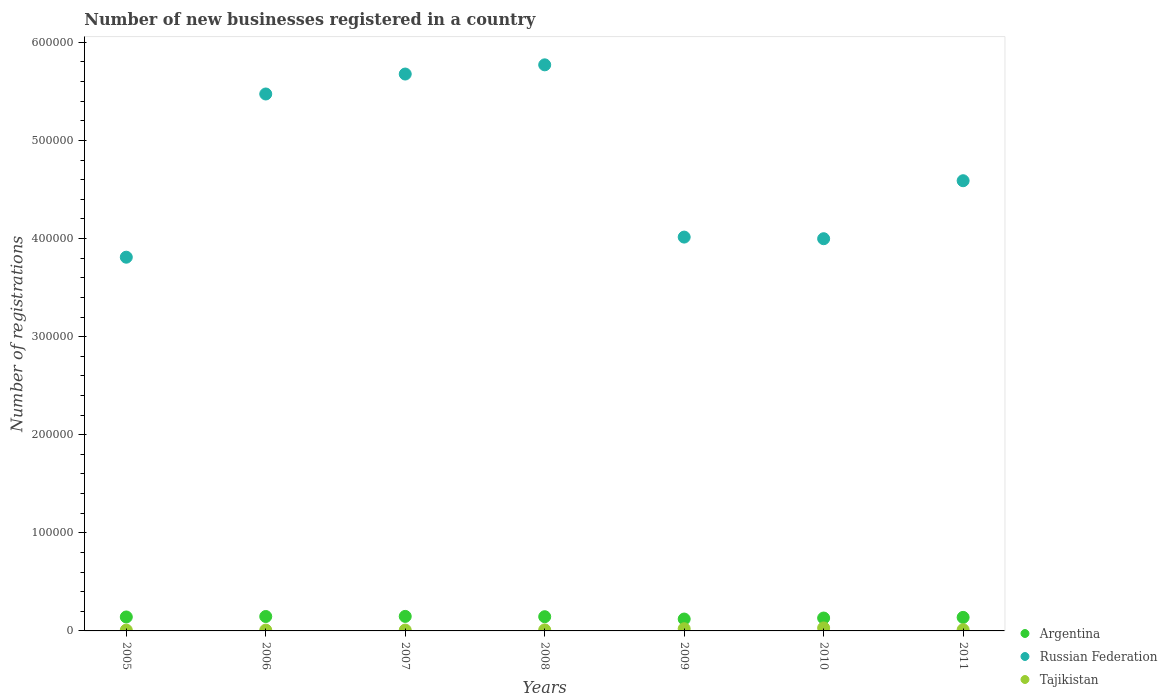Is the number of dotlines equal to the number of legend labels?
Your response must be concise. Yes. What is the number of new businesses registered in Tajikistan in 2008?
Ensure brevity in your answer.  1059. Across all years, what is the maximum number of new businesses registered in Tajikistan?
Give a very brief answer. 3048. Across all years, what is the minimum number of new businesses registered in Argentina?
Keep it short and to the point. 1.21e+04. What is the total number of new businesses registered in Russian Federation in the graph?
Offer a very short reply. 3.33e+06. What is the difference between the number of new businesses registered in Russian Federation in 2005 and that in 2009?
Your answer should be compact. -2.05e+04. What is the difference between the number of new businesses registered in Argentina in 2006 and the number of new businesses registered in Russian Federation in 2008?
Offer a very short reply. -5.62e+05. What is the average number of new businesses registered in Argentina per year?
Your response must be concise. 1.39e+04. In the year 2008, what is the difference between the number of new businesses registered in Tajikistan and number of new businesses registered in Argentina?
Offer a very short reply. -1.34e+04. In how many years, is the number of new businesses registered in Tajikistan greater than 580000?
Provide a succinct answer. 0. What is the ratio of the number of new businesses registered in Argentina in 2007 to that in 2010?
Your response must be concise. 1.13. Is the difference between the number of new businesses registered in Tajikistan in 2007 and 2008 greater than the difference between the number of new businesses registered in Argentina in 2007 and 2008?
Your answer should be very brief. No. What is the difference between the highest and the second highest number of new businesses registered in Russian Federation?
Offer a very short reply. 9377. What is the difference between the highest and the lowest number of new businesses registered in Tajikistan?
Offer a very short reply. 2204. In how many years, is the number of new businesses registered in Tajikistan greater than the average number of new businesses registered in Tajikistan taken over all years?
Your answer should be very brief. 2. Is the number of new businesses registered in Tajikistan strictly greater than the number of new businesses registered in Argentina over the years?
Ensure brevity in your answer.  No. Is the number of new businesses registered in Tajikistan strictly less than the number of new businesses registered in Russian Federation over the years?
Your answer should be compact. Yes. How many dotlines are there?
Your answer should be compact. 3. What is the difference between two consecutive major ticks on the Y-axis?
Offer a terse response. 1.00e+05. Are the values on the major ticks of Y-axis written in scientific E-notation?
Keep it short and to the point. No. Does the graph contain grids?
Your response must be concise. No. What is the title of the graph?
Ensure brevity in your answer.  Number of new businesses registered in a country. What is the label or title of the X-axis?
Your answer should be very brief. Years. What is the label or title of the Y-axis?
Keep it short and to the point. Number of registrations. What is the Number of registrations in Argentina in 2005?
Provide a succinct answer. 1.42e+04. What is the Number of registrations in Russian Federation in 2005?
Your answer should be compact. 3.81e+05. What is the Number of registrations of Tajikistan in 2005?
Make the answer very short. 844. What is the Number of registrations of Argentina in 2006?
Your response must be concise. 1.47e+04. What is the Number of registrations in Russian Federation in 2006?
Provide a succinct answer. 5.47e+05. What is the Number of registrations in Tajikistan in 2006?
Make the answer very short. 849. What is the Number of registrations of Argentina in 2007?
Keep it short and to the point. 1.48e+04. What is the Number of registrations of Russian Federation in 2007?
Your response must be concise. 5.68e+05. What is the Number of registrations of Tajikistan in 2007?
Give a very brief answer. 871. What is the Number of registrations of Argentina in 2008?
Keep it short and to the point. 1.45e+04. What is the Number of registrations of Russian Federation in 2008?
Your answer should be compact. 5.77e+05. What is the Number of registrations of Tajikistan in 2008?
Your answer should be very brief. 1059. What is the Number of registrations of Argentina in 2009?
Your answer should be very brief. 1.21e+04. What is the Number of registrations in Russian Federation in 2009?
Provide a succinct answer. 4.01e+05. What is the Number of registrations of Tajikistan in 2009?
Provide a short and direct response. 2219. What is the Number of registrations of Argentina in 2010?
Your answer should be very brief. 1.31e+04. What is the Number of registrations in Russian Federation in 2010?
Ensure brevity in your answer.  4.00e+05. What is the Number of registrations in Tajikistan in 2010?
Offer a very short reply. 3048. What is the Number of registrations in Argentina in 2011?
Your response must be concise. 1.38e+04. What is the Number of registrations of Russian Federation in 2011?
Give a very brief answer. 4.59e+05. What is the Number of registrations in Tajikistan in 2011?
Make the answer very short. 1232. Across all years, what is the maximum Number of registrations in Argentina?
Your answer should be compact. 1.48e+04. Across all years, what is the maximum Number of registrations in Russian Federation?
Keep it short and to the point. 5.77e+05. Across all years, what is the maximum Number of registrations of Tajikistan?
Offer a terse response. 3048. Across all years, what is the minimum Number of registrations in Argentina?
Your answer should be very brief. 1.21e+04. Across all years, what is the minimum Number of registrations of Russian Federation?
Provide a succinct answer. 3.81e+05. Across all years, what is the minimum Number of registrations of Tajikistan?
Offer a very short reply. 844. What is the total Number of registrations of Argentina in the graph?
Provide a short and direct response. 9.73e+04. What is the total Number of registrations in Russian Federation in the graph?
Provide a succinct answer. 3.33e+06. What is the total Number of registrations of Tajikistan in the graph?
Ensure brevity in your answer.  1.01e+04. What is the difference between the Number of registrations in Argentina in 2005 and that in 2006?
Your answer should be very brief. -475. What is the difference between the Number of registrations in Russian Federation in 2005 and that in 2006?
Your answer should be compact. -1.66e+05. What is the difference between the Number of registrations in Argentina in 2005 and that in 2007?
Offer a terse response. -586. What is the difference between the Number of registrations in Russian Federation in 2005 and that in 2007?
Your answer should be very brief. -1.87e+05. What is the difference between the Number of registrations of Tajikistan in 2005 and that in 2007?
Provide a short and direct response. -27. What is the difference between the Number of registrations of Argentina in 2005 and that in 2008?
Your answer should be very brief. -274. What is the difference between the Number of registrations in Russian Federation in 2005 and that in 2008?
Make the answer very short. -1.96e+05. What is the difference between the Number of registrations in Tajikistan in 2005 and that in 2008?
Keep it short and to the point. -215. What is the difference between the Number of registrations of Argentina in 2005 and that in 2009?
Your answer should be very brief. 2101. What is the difference between the Number of registrations in Russian Federation in 2005 and that in 2009?
Make the answer very short. -2.05e+04. What is the difference between the Number of registrations of Tajikistan in 2005 and that in 2009?
Keep it short and to the point. -1375. What is the difference between the Number of registrations of Argentina in 2005 and that in 2010?
Offer a very short reply. 1086. What is the difference between the Number of registrations of Russian Federation in 2005 and that in 2010?
Your answer should be very brief. -1.88e+04. What is the difference between the Number of registrations of Tajikistan in 2005 and that in 2010?
Keep it short and to the point. -2204. What is the difference between the Number of registrations in Argentina in 2005 and that in 2011?
Your answer should be very brief. 420. What is the difference between the Number of registrations of Russian Federation in 2005 and that in 2011?
Provide a short and direct response. -7.80e+04. What is the difference between the Number of registrations of Tajikistan in 2005 and that in 2011?
Provide a succinct answer. -388. What is the difference between the Number of registrations in Argentina in 2006 and that in 2007?
Provide a succinct answer. -111. What is the difference between the Number of registrations in Russian Federation in 2006 and that in 2007?
Give a very brief answer. -2.03e+04. What is the difference between the Number of registrations of Tajikistan in 2006 and that in 2007?
Your answer should be very brief. -22. What is the difference between the Number of registrations of Argentina in 2006 and that in 2008?
Keep it short and to the point. 201. What is the difference between the Number of registrations of Russian Federation in 2006 and that in 2008?
Ensure brevity in your answer.  -2.97e+04. What is the difference between the Number of registrations in Tajikistan in 2006 and that in 2008?
Your response must be concise. -210. What is the difference between the Number of registrations in Argentina in 2006 and that in 2009?
Your answer should be very brief. 2576. What is the difference between the Number of registrations in Russian Federation in 2006 and that in 2009?
Make the answer very short. 1.46e+05. What is the difference between the Number of registrations in Tajikistan in 2006 and that in 2009?
Give a very brief answer. -1370. What is the difference between the Number of registrations in Argentina in 2006 and that in 2010?
Your response must be concise. 1561. What is the difference between the Number of registrations in Russian Federation in 2006 and that in 2010?
Provide a succinct answer. 1.48e+05. What is the difference between the Number of registrations of Tajikistan in 2006 and that in 2010?
Provide a succinct answer. -2199. What is the difference between the Number of registrations in Argentina in 2006 and that in 2011?
Give a very brief answer. 895. What is the difference between the Number of registrations in Russian Federation in 2006 and that in 2011?
Ensure brevity in your answer.  8.84e+04. What is the difference between the Number of registrations in Tajikistan in 2006 and that in 2011?
Give a very brief answer. -383. What is the difference between the Number of registrations in Argentina in 2007 and that in 2008?
Provide a succinct answer. 312. What is the difference between the Number of registrations of Russian Federation in 2007 and that in 2008?
Keep it short and to the point. -9377. What is the difference between the Number of registrations of Tajikistan in 2007 and that in 2008?
Your answer should be compact. -188. What is the difference between the Number of registrations in Argentina in 2007 and that in 2009?
Offer a very short reply. 2687. What is the difference between the Number of registrations in Russian Federation in 2007 and that in 2009?
Ensure brevity in your answer.  1.66e+05. What is the difference between the Number of registrations of Tajikistan in 2007 and that in 2009?
Make the answer very short. -1348. What is the difference between the Number of registrations in Argentina in 2007 and that in 2010?
Provide a short and direct response. 1672. What is the difference between the Number of registrations in Russian Federation in 2007 and that in 2010?
Offer a very short reply. 1.68e+05. What is the difference between the Number of registrations of Tajikistan in 2007 and that in 2010?
Your response must be concise. -2177. What is the difference between the Number of registrations in Argentina in 2007 and that in 2011?
Your answer should be very brief. 1006. What is the difference between the Number of registrations of Russian Federation in 2007 and that in 2011?
Your answer should be compact. 1.09e+05. What is the difference between the Number of registrations in Tajikistan in 2007 and that in 2011?
Offer a terse response. -361. What is the difference between the Number of registrations in Argentina in 2008 and that in 2009?
Your response must be concise. 2375. What is the difference between the Number of registrations of Russian Federation in 2008 and that in 2009?
Your answer should be compact. 1.76e+05. What is the difference between the Number of registrations of Tajikistan in 2008 and that in 2009?
Your answer should be very brief. -1160. What is the difference between the Number of registrations of Argentina in 2008 and that in 2010?
Provide a succinct answer. 1360. What is the difference between the Number of registrations of Russian Federation in 2008 and that in 2010?
Make the answer very short. 1.77e+05. What is the difference between the Number of registrations of Tajikistan in 2008 and that in 2010?
Ensure brevity in your answer.  -1989. What is the difference between the Number of registrations in Argentina in 2008 and that in 2011?
Offer a very short reply. 694. What is the difference between the Number of registrations in Russian Federation in 2008 and that in 2011?
Make the answer very short. 1.18e+05. What is the difference between the Number of registrations of Tajikistan in 2008 and that in 2011?
Provide a succinct answer. -173. What is the difference between the Number of registrations in Argentina in 2009 and that in 2010?
Your response must be concise. -1015. What is the difference between the Number of registrations of Russian Federation in 2009 and that in 2010?
Your answer should be very brief. 1653. What is the difference between the Number of registrations in Tajikistan in 2009 and that in 2010?
Ensure brevity in your answer.  -829. What is the difference between the Number of registrations of Argentina in 2009 and that in 2011?
Your answer should be compact. -1681. What is the difference between the Number of registrations in Russian Federation in 2009 and that in 2011?
Your answer should be very brief. -5.75e+04. What is the difference between the Number of registrations of Tajikistan in 2009 and that in 2011?
Make the answer very short. 987. What is the difference between the Number of registrations in Argentina in 2010 and that in 2011?
Provide a succinct answer. -666. What is the difference between the Number of registrations in Russian Federation in 2010 and that in 2011?
Your answer should be compact. -5.91e+04. What is the difference between the Number of registrations of Tajikistan in 2010 and that in 2011?
Offer a terse response. 1816. What is the difference between the Number of registrations in Argentina in 2005 and the Number of registrations in Russian Federation in 2006?
Give a very brief answer. -5.33e+05. What is the difference between the Number of registrations of Argentina in 2005 and the Number of registrations of Tajikistan in 2006?
Give a very brief answer. 1.34e+04. What is the difference between the Number of registrations of Russian Federation in 2005 and the Number of registrations of Tajikistan in 2006?
Your answer should be very brief. 3.80e+05. What is the difference between the Number of registrations of Argentina in 2005 and the Number of registrations of Russian Federation in 2007?
Give a very brief answer. -5.53e+05. What is the difference between the Number of registrations in Argentina in 2005 and the Number of registrations in Tajikistan in 2007?
Your response must be concise. 1.33e+04. What is the difference between the Number of registrations of Russian Federation in 2005 and the Number of registrations of Tajikistan in 2007?
Ensure brevity in your answer.  3.80e+05. What is the difference between the Number of registrations of Argentina in 2005 and the Number of registrations of Russian Federation in 2008?
Keep it short and to the point. -5.63e+05. What is the difference between the Number of registrations of Argentina in 2005 and the Number of registrations of Tajikistan in 2008?
Your answer should be very brief. 1.32e+04. What is the difference between the Number of registrations in Russian Federation in 2005 and the Number of registrations in Tajikistan in 2008?
Provide a short and direct response. 3.80e+05. What is the difference between the Number of registrations of Argentina in 2005 and the Number of registrations of Russian Federation in 2009?
Keep it short and to the point. -3.87e+05. What is the difference between the Number of registrations in Argentina in 2005 and the Number of registrations in Tajikistan in 2009?
Provide a succinct answer. 1.20e+04. What is the difference between the Number of registrations in Russian Federation in 2005 and the Number of registrations in Tajikistan in 2009?
Ensure brevity in your answer.  3.79e+05. What is the difference between the Number of registrations of Argentina in 2005 and the Number of registrations of Russian Federation in 2010?
Offer a terse response. -3.86e+05. What is the difference between the Number of registrations in Argentina in 2005 and the Number of registrations in Tajikistan in 2010?
Offer a terse response. 1.12e+04. What is the difference between the Number of registrations in Russian Federation in 2005 and the Number of registrations in Tajikistan in 2010?
Provide a succinct answer. 3.78e+05. What is the difference between the Number of registrations of Argentina in 2005 and the Number of registrations of Russian Federation in 2011?
Your response must be concise. -4.45e+05. What is the difference between the Number of registrations in Argentina in 2005 and the Number of registrations in Tajikistan in 2011?
Your answer should be very brief. 1.30e+04. What is the difference between the Number of registrations in Russian Federation in 2005 and the Number of registrations in Tajikistan in 2011?
Your answer should be very brief. 3.80e+05. What is the difference between the Number of registrations of Argentina in 2006 and the Number of registrations of Russian Federation in 2007?
Offer a very short reply. -5.53e+05. What is the difference between the Number of registrations of Argentina in 2006 and the Number of registrations of Tajikistan in 2007?
Your answer should be compact. 1.38e+04. What is the difference between the Number of registrations in Russian Federation in 2006 and the Number of registrations in Tajikistan in 2007?
Provide a short and direct response. 5.46e+05. What is the difference between the Number of registrations of Argentina in 2006 and the Number of registrations of Russian Federation in 2008?
Give a very brief answer. -5.62e+05. What is the difference between the Number of registrations in Argentina in 2006 and the Number of registrations in Tajikistan in 2008?
Provide a short and direct response. 1.36e+04. What is the difference between the Number of registrations of Russian Federation in 2006 and the Number of registrations of Tajikistan in 2008?
Give a very brief answer. 5.46e+05. What is the difference between the Number of registrations of Argentina in 2006 and the Number of registrations of Russian Federation in 2009?
Offer a terse response. -3.87e+05. What is the difference between the Number of registrations of Argentina in 2006 and the Number of registrations of Tajikistan in 2009?
Your answer should be compact. 1.25e+04. What is the difference between the Number of registrations in Russian Federation in 2006 and the Number of registrations in Tajikistan in 2009?
Give a very brief answer. 5.45e+05. What is the difference between the Number of registrations of Argentina in 2006 and the Number of registrations of Russian Federation in 2010?
Offer a very short reply. -3.85e+05. What is the difference between the Number of registrations in Argentina in 2006 and the Number of registrations in Tajikistan in 2010?
Provide a succinct answer. 1.16e+04. What is the difference between the Number of registrations of Russian Federation in 2006 and the Number of registrations of Tajikistan in 2010?
Keep it short and to the point. 5.44e+05. What is the difference between the Number of registrations in Argentina in 2006 and the Number of registrations in Russian Federation in 2011?
Provide a short and direct response. -4.44e+05. What is the difference between the Number of registrations of Argentina in 2006 and the Number of registrations of Tajikistan in 2011?
Offer a terse response. 1.35e+04. What is the difference between the Number of registrations of Russian Federation in 2006 and the Number of registrations of Tajikistan in 2011?
Your response must be concise. 5.46e+05. What is the difference between the Number of registrations in Argentina in 2007 and the Number of registrations in Russian Federation in 2008?
Your answer should be very brief. -5.62e+05. What is the difference between the Number of registrations of Argentina in 2007 and the Number of registrations of Tajikistan in 2008?
Keep it short and to the point. 1.37e+04. What is the difference between the Number of registrations in Russian Federation in 2007 and the Number of registrations in Tajikistan in 2008?
Give a very brief answer. 5.67e+05. What is the difference between the Number of registrations in Argentina in 2007 and the Number of registrations in Russian Federation in 2009?
Your response must be concise. -3.87e+05. What is the difference between the Number of registrations of Argentina in 2007 and the Number of registrations of Tajikistan in 2009?
Your answer should be very brief. 1.26e+04. What is the difference between the Number of registrations of Russian Federation in 2007 and the Number of registrations of Tajikistan in 2009?
Give a very brief answer. 5.65e+05. What is the difference between the Number of registrations in Argentina in 2007 and the Number of registrations in Russian Federation in 2010?
Make the answer very short. -3.85e+05. What is the difference between the Number of registrations of Argentina in 2007 and the Number of registrations of Tajikistan in 2010?
Ensure brevity in your answer.  1.18e+04. What is the difference between the Number of registrations of Russian Federation in 2007 and the Number of registrations of Tajikistan in 2010?
Your answer should be compact. 5.65e+05. What is the difference between the Number of registrations of Argentina in 2007 and the Number of registrations of Russian Federation in 2011?
Make the answer very short. -4.44e+05. What is the difference between the Number of registrations in Argentina in 2007 and the Number of registrations in Tajikistan in 2011?
Offer a very short reply. 1.36e+04. What is the difference between the Number of registrations in Russian Federation in 2007 and the Number of registrations in Tajikistan in 2011?
Give a very brief answer. 5.66e+05. What is the difference between the Number of registrations of Argentina in 2008 and the Number of registrations of Russian Federation in 2009?
Keep it short and to the point. -3.87e+05. What is the difference between the Number of registrations of Argentina in 2008 and the Number of registrations of Tajikistan in 2009?
Offer a terse response. 1.23e+04. What is the difference between the Number of registrations in Russian Federation in 2008 and the Number of registrations in Tajikistan in 2009?
Offer a very short reply. 5.75e+05. What is the difference between the Number of registrations in Argentina in 2008 and the Number of registrations in Russian Federation in 2010?
Give a very brief answer. -3.85e+05. What is the difference between the Number of registrations of Argentina in 2008 and the Number of registrations of Tajikistan in 2010?
Your answer should be very brief. 1.14e+04. What is the difference between the Number of registrations in Russian Federation in 2008 and the Number of registrations in Tajikistan in 2010?
Your response must be concise. 5.74e+05. What is the difference between the Number of registrations in Argentina in 2008 and the Number of registrations in Russian Federation in 2011?
Your answer should be very brief. -4.44e+05. What is the difference between the Number of registrations in Argentina in 2008 and the Number of registrations in Tajikistan in 2011?
Offer a terse response. 1.33e+04. What is the difference between the Number of registrations in Russian Federation in 2008 and the Number of registrations in Tajikistan in 2011?
Offer a terse response. 5.76e+05. What is the difference between the Number of registrations of Argentina in 2009 and the Number of registrations of Russian Federation in 2010?
Your response must be concise. -3.88e+05. What is the difference between the Number of registrations of Argentina in 2009 and the Number of registrations of Tajikistan in 2010?
Offer a very short reply. 9070. What is the difference between the Number of registrations in Russian Federation in 2009 and the Number of registrations in Tajikistan in 2010?
Provide a short and direct response. 3.98e+05. What is the difference between the Number of registrations of Argentina in 2009 and the Number of registrations of Russian Federation in 2011?
Ensure brevity in your answer.  -4.47e+05. What is the difference between the Number of registrations in Argentina in 2009 and the Number of registrations in Tajikistan in 2011?
Provide a short and direct response. 1.09e+04. What is the difference between the Number of registrations of Russian Federation in 2009 and the Number of registrations of Tajikistan in 2011?
Give a very brief answer. 4.00e+05. What is the difference between the Number of registrations in Argentina in 2010 and the Number of registrations in Russian Federation in 2011?
Your answer should be very brief. -4.46e+05. What is the difference between the Number of registrations in Argentina in 2010 and the Number of registrations in Tajikistan in 2011?
Keep it short and to the point. 1.19e+04. What is the difference between the Number of registrations in Russian Federation in 2010 and the Number of registrations in Tajikistan in 2011?
Your answer should be compact. 3.99e+05. What is the average Number of registrations in Argentina per year?
Your answer should be compact. 1.39e+04. What is the average Number of registrations of Russian Federation per year?
Ensure brevity in your answer.  4.76e+05. What is the average Number of registrations of Tajikistan per year?
Offer a very short reply. 1446. In the year 2005, what is the difference between the Number of registrations of Argentina and Number of registrations of Russian Federation?
Your answer should be compact. -3.67e+05. In the year 2005, what is the difference between the Number of registrations in Argentina and Number of registrations in Tajikistan?
Offer a very short reply. 1.34e+04. In the year 2005, what is the difference between the Number of registrations of Russian Federation and Number of registrations of Tajikistan?
Offer a terse response. 3.80e+05. In the year 2006, what is the difference between the Number of registrations of Argentina and Number of registrations of Russian Federation?
Give a very brief answer. -5.33e+05. In the year 2006, what is the difference between the Number of registrations in Argentina and Number of registrations in Tajikistan?
Provide a short and direct response. 1.38e+04. In the year 2006, what is the difference between the Number of registrations of Russian Federation and Number of registrations of Tajikistan?
Make the answer very short. 5.47e+05. In the year 2007, what is the difference between the Number of registrations in Argentina and Number of registrations in Russian Federation?
Ensure brevity in your answer.  -5.53e+05. In the year 2007, what is the difference between the Number of registrations of Argentina and Number of registrations of Tajikistan?
Ensure brevity in your answer.  1.39e+04. In the year 2007, what is the difference between the Number of registrations of Russian Federation and Number of registrations of Tajikistan?
Offer a very short reply. 5.67e+05. In the year 2008, what is the difference between the Number of registrations in Argentina and Number of registrations in Russian Federation?
Make the answer very short. -5.63e+05. In the year 2008, what is the difference between the Number of registrations in Argentina and Number of registrations in Tajikistan?
Keep it short and to the point. 1.34e+04. In the year 2008, what is the difference between the Number of registrations of Russian Federation and Number of registrations of Tajikistan?
Keep it short and to the point. 5.76e+05. In the year 2009, what is the difference between the Number of registrations in Argentina and Number of registrations in Russian Federation?
Keep it short and to the point. -3.89e+05. In the year 2009, what is the difference between the Number of registrations in Argentina and Number of registrations in Tajikistan?
Your answer should be compact. 9899. In the year 2009, what is the difference between the Number of registrations of Russian Federation and Number of registrations of Tajikistan?
Provide a succinct answer. 3.99e+05. In the year 2010, what is the difference between the Number of registrations in Argentina and Number of registrations in Russian Federation?
Provide a succinct answer. -3.87e+05. In the year 2010, what is the difference between the Number of registrations in Argentina and Number of registrations in Tajikistan?
Ensure brevity in your answer.  1.01e+04. In the year 2010, what is the difference between the Number of registrations of Russian Federation and Number of registrations of Tajikistan?
Give a very brief answer. 3.97e+05. In the year 2011, what is the difference between the Number of registrations of Argentina and Number of registrations of Russian Federation?
Make the answer very short. -4.45e+05. In the year 2011, what is the difference between the Number of registrations of Argentina and Number of registrations of Tajikistan?
Your answer should be very brief. 1.26e+04. In the year 2011, what is the difference between the Number of registrations in Russian Federation and Number of registrations in Tajikistan?
Your response must be concise. 4.58e+05. What is the ratio of the Number of registrations of Russian Federation in 2005 to that in 2006?
Ensure brevity in your answer.  0.7. What is the ratio of the Number of registrations in Tajikistan in 2005 to that in 2006?
Your answer should be very brief. 0.99. What is the ratio of the Number of registrations of Argentina in 2005 to that in 2007?
Offer a terse response. 0.96. What is the ratio of the Number of registrations of Russian Federation in 2005 to that in 2007?
Offer a very short reply. 0.67. What is the ratio of the Number of registrations of Argentina in 2005 to that in 2008?
Offer a terse response. 0.98. What is the ratio of the Number of registrations in Russian Federation in 2005 to that in 2008?
Provide a short and direct response. 0.66. What is the ratio of the Number of registrations in Tajikistan in 2005 to that in 2008?
Make the answer very short. 0.8. What is the ratio of the Number of registrations in Argentina in 2005 to that in 2009?
Provide a succinct answer. 1.17. What is the ratio of the Number of registrations in Russian Federation in 2005 to that in 2009?
Keep it short and to the point. 0.95. What is the ratio of the Number of registrations of Tajikistan in 2005 to that in 2009?
Your answer should be compact. 0.38. What is the ratio of the Number of registrations in Argentina in 2005 to that in 2010?
Keep it short and to the point. 1.08. What is the ratio of the Number of registrations in Russian Federation in 2005 to that in 2010?
Keep it short and to the point. 0.95. What is the ratio of the Number of registrations in Tajikistan in 2005 to that in 2010?
Offer a very short reply. 0.28. What is the ratio of the Number of registrations of Argentina in 2005 to that in 2011?
Your answer should be compact. 1.03. What is the ratio of the Number of registrations of Russian Federation in 2005 to that in 2011?
Provide a short and direct response. 0.83. What is the ratio of the Number of registrations in Tajikistan in 2005 to that in 2011?
Offer a terse response. 0.69. What is the ratio of the Number of registrations in Russian Federation in 2006 to that in 2007?
Provide a succinct answer. 0.96. What is the ratio of the Number of registrations in Tajikistan in 2006 to that in 2007?
Offer a very short reply. 0.97. What is the ratio of the Number of registrations in Argentina in 2006 to that in 2008?
Offer a very short reply. 1.01. What is the ratio of the Number of registrations in Russian Federation in 2006 to that in 2008?
Your answer should be compact. 0.95. What is the ratio of the Number of registrations of Tajikistan in 2006 to that in 2008?
Your answer should be compact. 0.8. What is the ratio of the Number of registrations in Argentina in 2006 to that in 2009?
Your answer should be compact. 1.21. What is the ratio of the Number of registrations in Russian Federation in 2006 to that in 2009?
Give a very brief answer. 1.36. What is the ratio of the Number of registrations of Tajikistan in 2006 to that in 2009?
Offer a terse response. 0.38. What is the ratio of the Number of registrations of Argentina in 2006 to that in 2010?
Offer a very short reply. 1.12. What is the ratio of the Number of registrations in Russian Federation in 2006 to that in 2010?
Offer a terse response. 1.37. What is the ratio of the Number of registrations of Tajikistan in 2006 to that in 2010?
Your response must be concise. 0.28. What is the ratio of the Number of registrations in Argentina in 2006 to that in 2011?
Provide a succinct answer. 1.06. What is the ratio of the Number of registrations of Russian Federation in 2006 to that in 2011?
Provide a succinct answer. 1.19. What is the ratio of the Number of registrations in Tajikistan in 2006 to that in 2011?
Your answer should be very brief. 0.69. What is the ratio of the Number of registrations of Argentina in 2007 to that in 2008?
Make the answer very short. 1.02. What is the ratio of the Number of registrations in Russian Federation in 2007 to that in 2008?
Ensure brevity in your answer.  0.98. What is the ratio of the Number of registrations in Tajikistan in 2007 to that in 2008?
Your answer should be very brief. 0.82. What is the ratio of the Number of registrations of Argentina in 2007 to that in 2009?
Make the answer very short. 1.22. What is the ratio of the Number of registrations in Russian Federation in 2007 to that in 2009?
Make the answer very short. 1.41. What is the ratio of the Number of registrations of Tajikistan in 2007 to that in 2009?
Provide a succinct answer. 0.39. What is the ratio of the Number of registrations in Argentina in 2007 to that in 2010?
Provide a short and direct response. 1.13. What is the ratio of the Number of registrations in Russian Federation in 2007 to that in 2010?
Provide a succinct answer. 1.42. What is the ratio of the Number of registrations in Tajikistan in 2007 to that in 2010?
Ensure brevity in your answer.  0.29. What is the ratio of the Number of registrations of Argentina in 2007 to that in 2011?
Your answer should be compact. 1.07. What is the ratio of the Number of registrations in Russian Federation in 2007 to that in 2011?
Offer a very short reply. 1.24. What is the ratio of the Number of registrations of Tajikistan in 2007 to that in 2011?
Make the answer very short. 0.71. What is the ratio of the Number of registrations in Argentina in 2008 to that in 2009?
Give a very brief answer. 1.2. What is the ratio of the Number of registrations in Russian Federation in 2008 to that in 2009?
Give a very brief answer. 1.44. What is the ratio of the Number of registrations in Tajikistan in 2008 to that in 2009?
Offer a terse response. 0.48. What is the ratio of the Number of registrations in Argentina in 2008 to that in 2010?
Offer a terse response. 1.1. What is the ratio of the Number of registrations in Russian Federation in 2008 to that in 2010?
Give a very brief answer. 1.44. What is the ratio of the Number of registrations in Tajikistan in 2008 to that in 2010?
Offer a terse response. 0.35. What is the ratio of the Number of registrations of Argentina in 2008 to that in 2011?
Your answer should be compact. 1.05. What is the ratio of the Number of registrations in Russian Federation in 2008 to that in 2011?
Make the answer very short. 1.26. What is the ratio of the Number of registrations in Tajikistan in 2008 to that in 2011?
Offer a very short reply. 0.86. What is the ratio of the Number of registrations of Argentina in 2009 to that in 2010?
Your answer should be very brief. 0.92. What is the ratio of the Number of registrations of Tajikistan in 2009 to that in 2010?
Your response must be concise. 0.73. What is the ratio of the Number of registrations in Argentina in 2009 to that in 2011?
Offer a terse response. 0.88. What is the ratio of the Number of registrations in Russian Federation in 2009 to that in 2011?
Offer a terse response. 0.87. What is the ratio of the Number of registrations of Tajikistan in 2009 to that in 2011?
Your answer should be compact. 1.8. What is the ratio of the Number of registrations of Argentina in 2010 to that in 2011?
Your answer should be compact. 0.95. What is the ratio of the Number of registrations of Russian Federation in 2010 to that in 2011?
Give a very brief answer. 0.87. What is the ratio of the Number of registrations of Tajikistan in 2010 to that in 2011?
Keep it short and to the point. 2.47. What is the difference between the highest and the second highest Number of registrations of Argentina?
Ensure brevity in your answer.  111. What is the difference between the highest and the second highest Number of registrations of Russian Federation?
Your answer should be compact. 9377. What is the difference between the highest and the second highest Number of registrations in Tajikistan?
Ensure brevity in your answer.  829. What is the difference between the highest and the lowest Number of registrations of Argentina?
Your answer should be compact. 2687. What is the difference between the highest and the lowest Number of registrations of Russian Federation?
Provide a short and direct response. 1.96e+05. What is the difference between the highest and the lowest Number of registrations of Tajikistan?
Your answer should be compact. 2204. 